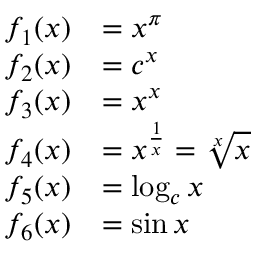Convert formula to latex. <formula><loc_0><loc_0><loc_500><loc_500>{ \begin{array} { r l } { f _ { 1 } ( x ) } & { = x ^ { \pi } } \\ { f _ { 2 } ( x ) } & { = c ^ { x } } \\ { f _ { 3 } ( x ) } & { = x ^ { x } } \\ { f _ { 4 } ( x ) } & { = x ^ { \frac { 1 } { x } } = { \sqrt { [ } { x } ] { x } } } \\ { f _ { 5 } ( x ) } & { = \log _ { c } x } \\ { f _ { 6 } ( x ) } & { = \sin { x } } \end{array} }</formula> 